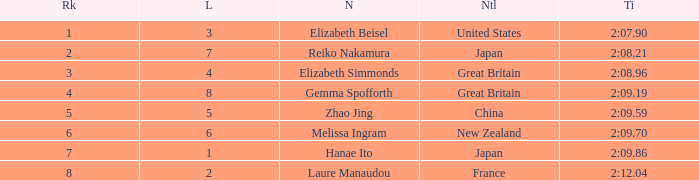What is Laure Manaudou's highest rank? 8.0. Would you be able to parse every entry in this table? {'header': ['Rk', 'L', 'N', 'Ntl', 'Ti'], 'rows': [['1', '3', 'Elizabeth Beisel', 'United States', '2:07.90'], ['2', '7', 'Reiko Nakamura', 'Japan', '2:08.21'], ['3', '4', 'Elizabeth Simmonds', 'Great Britain', '2:08.96'], ['4', '8', 'Gemma Spofforth', 'Great Britain', '2:09.19'], ['5', '5', 'Zhao Jing', 'China', '2:09.59'], ['6', '6', 'Melissa Ingram', 'New Zealand', '2:09.70'], ['7', '1', 'Hanae Ito', 'Japan', '2:09.86'], ['8', '2', 'Laure Manaudou', 'France', '2:12.04']]} 